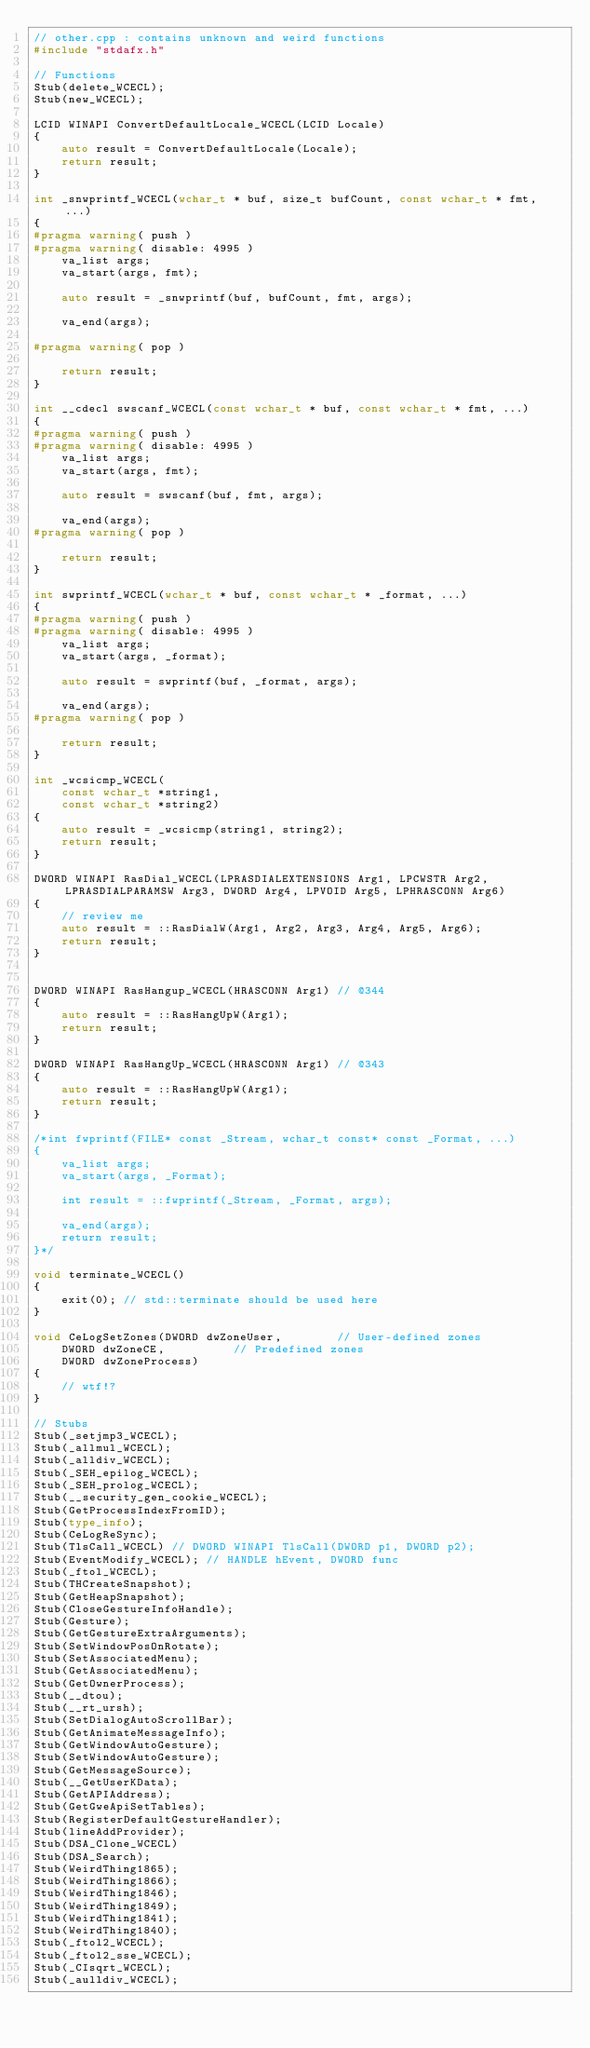Convert code to text. <code><loc_0><loc_0><loc_500><loc_500><_C++_>// other.cpp : contains unknown and weird functions
#include "stdafx.h"

// Functions
Stub(delete_WCECL);
Stub(new_WCECL);

LCID WINAPI ConvertDefaultLocale_WCECL(LCID Locale)
{
	auto result = ConvertDefaultLocale(Locale);
	return result;
}

int _snwprintf_WCECL(wchar_t * buf, size_t bufCount, const wchar_t * fmt, ...)
{
#pragma warning( push )
#pragma warning( disable: 4995 )
	va_list args;
	va_start(args, fmt);

	auto result = _snwprintf(buf, bufCount, fmt, args);

	va_end(args);

#pragma warning( pop )

	return result;
}

int __cdecl swscanf_WCECL(const wchar_t * buf, const wchar_t * fmt, ...)
{
#pragma warning( push )
#pragma warning( disable: 4995 )
	va_list args;
	va_start(args, fmt);

	auto result = swscanf(buf, fmt, args);

	va_end(args);
#pragma warning( pop )

	return result;
}

int swprintf_WCECL(wchar_t * buf, const wchar_t * _format, ...)
{
#pragma warning( push )
#pragma warning( disable: 4995 )
	va_list args;
	va_start(args, _format);

	auto result = swprintf(buf, _format, args);

	va_end(args);
#pragma warning( pop )

	return result;
}

int _wcsicmp_WCECL(
	const wchar_t *string1,
	const wchar_t *string2)
{
	auto result = _wcsicmp(string1, string2);
	return result;
}

DWORD WINAPI RasDial_WCECL(LPRASDIALEXTENSIONS Arg1, LPCWSTR Arg2, LPRASDIALPARAMSW Arg3, DWORD Arg4, LPVOID Arg5, LPHRASCONN Arg6)
{
	// review me
	auto result = ::RasDialW(Arg1, Arg2, Arg3, Arg4, Arg5, Arg6);
	return result;
}


DWORD WINAPI RasHangup_WCECL(HRASCONN Arg1) // @344
{
	auto result = ::RasHangUpW(Arg1);
	return result;
}

DWORD WINAPI RasHangUp_WCECL(HRASCONN Arg1) // @343
{
	auto result = ::RasHangUpW(Arg1);
	return result;
}

/*int fwprintf(FILE* const _Stream, wchar_t const* const _Format, ...)
{
	va_list args;
	va_start(args, _Format);

	int result = ::fwprintf(_Stream, _Format, args);

	va_end(args);
	return result;
}*/

void terminate_WCECL()
{
	exit(0); // std::terminate should be used here
}

void CeLogSetZones(DWORD dwZoneUser,        // User-defined zones
	DWORD dwZoneCE,          // Predefined zones
	DWORD dwZoneProcess)
{
	// wtf!?
}

// Stubs
Stub(_setjmp3_WCECL);
Stub(_allmul_WCECL);
Stub(_alldiv_WCECL);
Stub(_SEH_epilog_WCECL);
Stub(_SEH_prolog_WCECL);
Stub(__security_gen_cookie_WCECL);
Stub(GetProcessIndexFromID);
Stub(type_info);
Stub(CeLogReSync);
Stub(TlsCall_WCECL) // DWORD WINAPI TlsCall(DWORD p1, DWORD p2);
Stub(EventModify_WCECL); // HANDLE hEvent, DWORD func
Stub(_ftol_WCECL);
Stub(THCreateSnapshot);
Stub(GetHeapSnapshot);
Stub(CloseGestureInfoHandle);
Stub(Gesture);
Stub(GetGestureExtraArguments);
Stub(SetWindowPosOnRotate);
Stub(SetAssociatedMenu);
Stub(GetAssociatedMenu);
Stub(GetOwnerProcess);
Stub(__dtou);
Stub(__rt_ursh);
Stub(SetDialogAutoScrollBar);
Stub(GetAnimateMessageInfo);
Stub(GetWindowAutoGesture);
Stub(SetWindowAutoGesture);
Stub(GetMessageSource);
Stub(__GetUserKData);
Stub(GetAPIAddress);
Stub(GetGweApiSetTables);
Stub(RegisterDefaultGestureHandler);
Stub(lineAddProvider);
Stub(DSA_Clone_WCECL)
Stub(DSA_Search);
Stub(WeirdThing1865);
Stub(WeirdThing1866);
Stub(WeirdThing1846);
Stub(WeirdThing1849);
Stub(WeirdThing1841);
Stub(WeirdThing1840);
Stub(_ftol2_WCECL);
Stub(_ftol2_sse_WCECL);
Stub(_CIsqrt_WCECL);
Stub(_aulldiv_WCECL);
</code> 